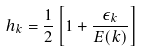Convert formula to latex. <formula><loc_0><loc_0><loc_500><loc_500>h _ { k } = \frac { 1 } { 2 } \left [ 1 + \frac { \epsilon _ { k } } { E ( { k } ) } \right ]</formula> 